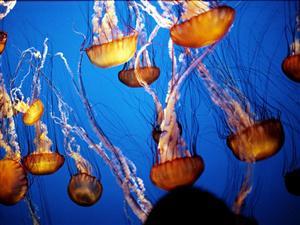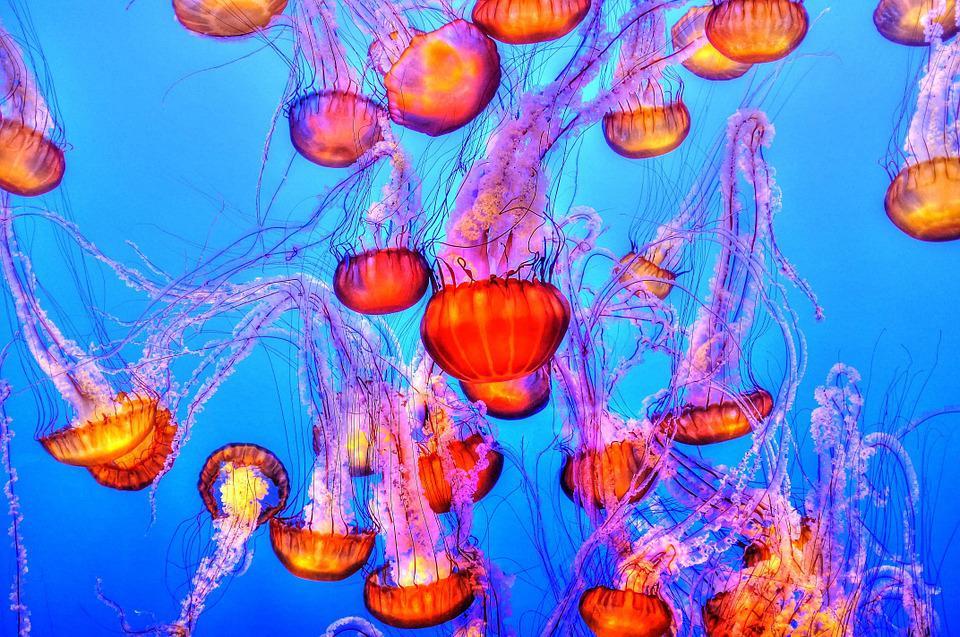The first image is the image on the left, the second image is the image on the right. For the images shown, is this caption "all of the jellyfish are swimming with the body facing downward" true? Answer yes or no. Yes. The first image is the image on the left, the second image is the image on the right. Evaluate the accuracy of this statement regarding the images: "There are at least 7 jellyfish swimming down.". Is it true? Answer yes or no. Yes. 